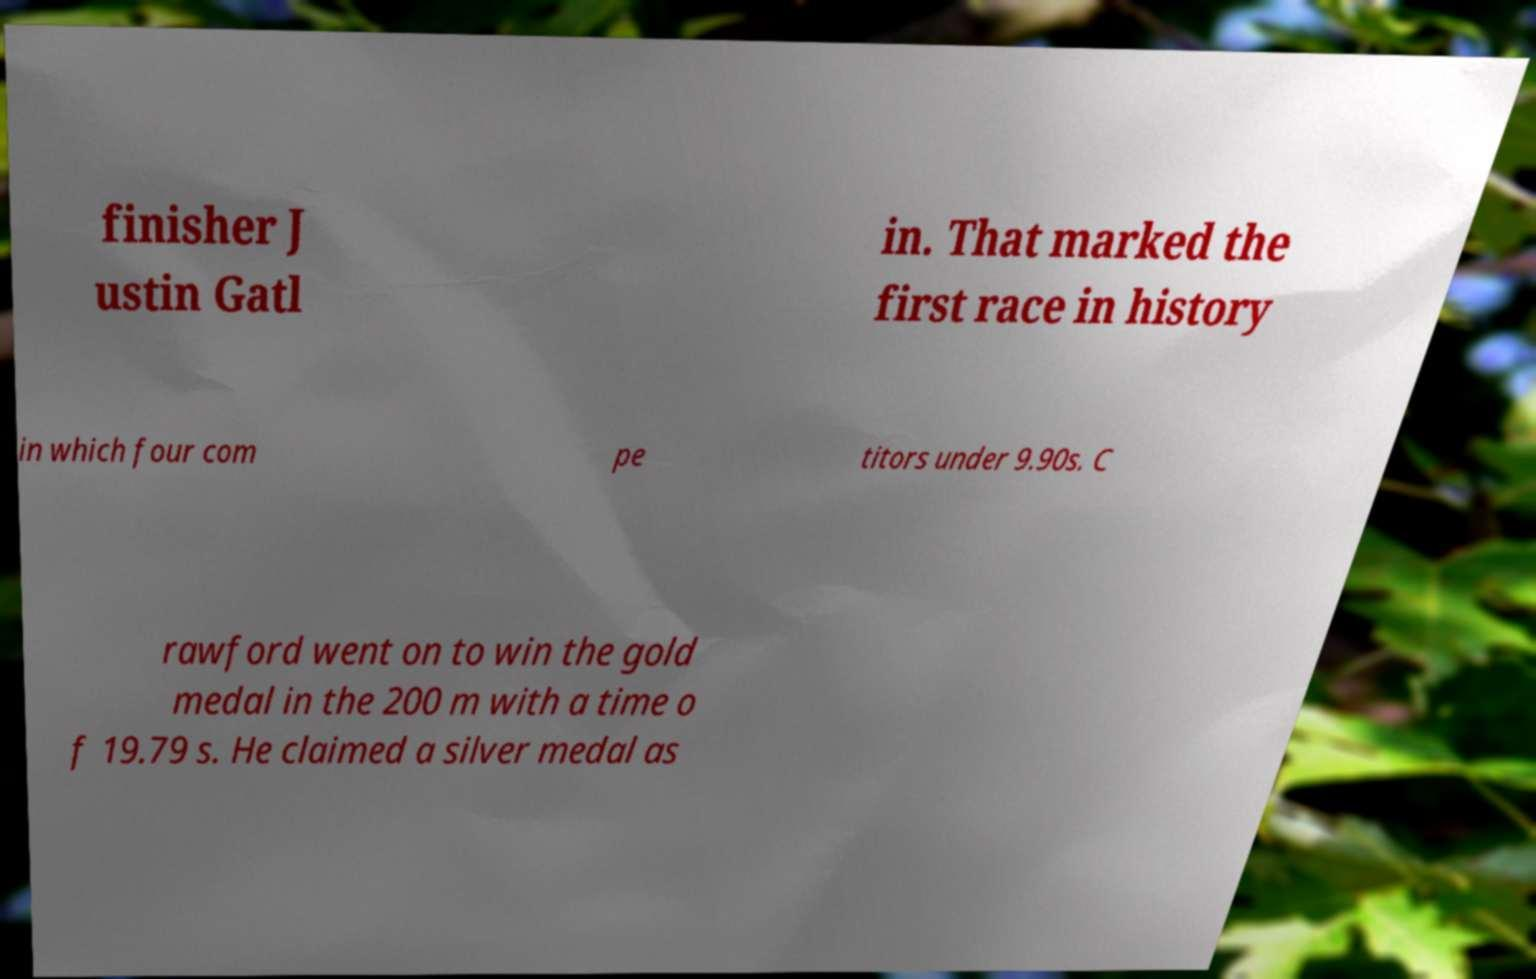I need the written content from this picture converted into text. Can you do that? finisher J ustin Gatl in. That marked the first race in history in which four com pe titors under 9.90s. C rawford went on to win the gold medal in the 200 m with a time o f 19.79 s. He claimed a silver medal as 